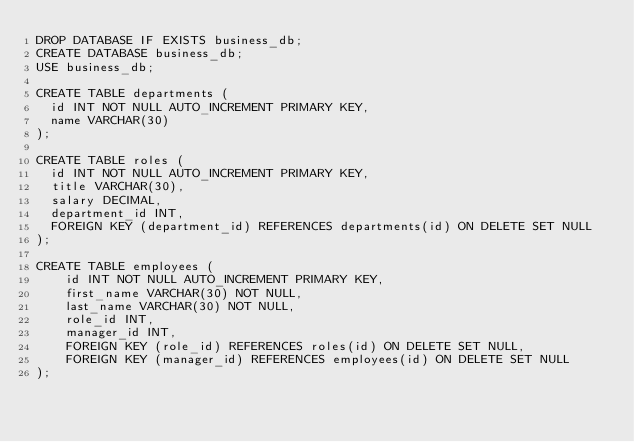Convert code to text. <code><loc_0><loc_0><loc_500><loc_500><_SQL_>DROP DATABASE IF EXISTS business_db;
CREATE DATABASE business_db;
USE business_db;

CREATE TABLE departments (
  id INT NOT NULL AUTO_INCREMENT PRIMARY KEY,
  name VARCHAR(30)
);

CREATE TABLE roles (
  id INT NOT NULL AUTO_INCREMENT PRIMARY KEY,
  title VARCHAR(30),
  salary DECIMAL,
  department_id INT,
  FOREIGN KEY (department_id) REFERENCES departments(id) ON DELETE SET NULL
);

CREATE TABLE employees (
    id INT NOT NULL AUTO_INCREMENT PRIMARY KEY,
    first_name VARCHAR(30) NOT NULL,
    last_name VARCHAR(30) NOT NULL,
    role_id INT,
    manager_id INT,
    FOREIGN KEY (role_id) REFERENCES roles(id) ON DELETE SET NULL,
    FOREIGN KEY (manager_id) REFERENCES employees(id) ON DELETE SET NULL
);</code> 